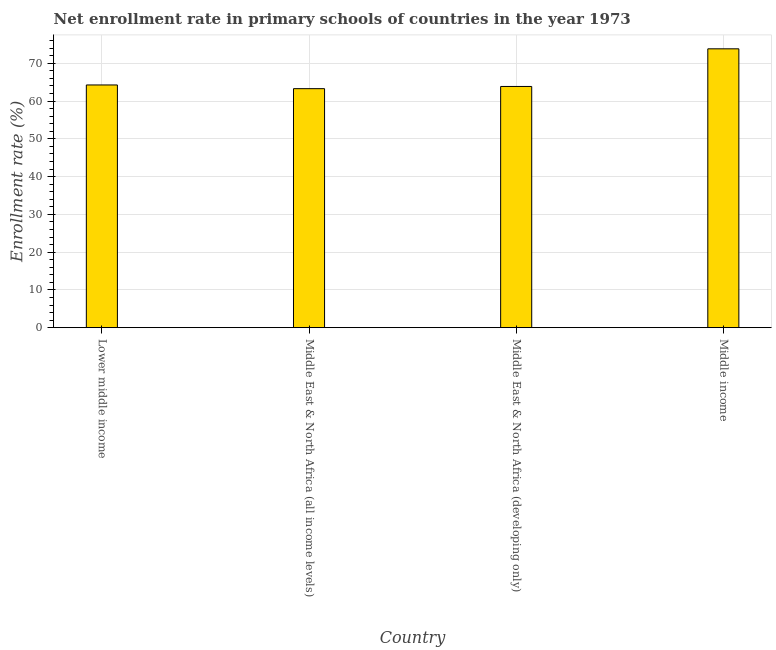What is the title of the graph?
Keep it short and to the point. Net enrollment rate in primary schools of countries in the year 1973. What is the label or title of the X-axis?
Keep it short and to the point. Country. What is the label or title of the Y-axis?
Ensure brevity in your answer.  Enrollment rate (%). What is the net enrollment rate in primary schools in Middle income?
Give a very brief answer. 73.83. Across all countries, what is the maximum net enrollment rate in primary schools?
Make the answer very short. 73.83. Across all countries, what is the minimum net enrollment rate in primary schools?
Your answer should be very brief. 63.28. In which country was the net enrollment rate in primary schools minimum?
Your answer should be very brief. Middle East & North Africa (all income levels). What is the sum of the net enrollment rate in primary schools?
Provide a succinct answer. 265.24. What is the difference between the net enrollment rate in primary schools in Lower middle income and Middle income?
Provide a short and direct response. -9.57. What is the average net enrollment rate in primary schools per country?
Offer a terse response. 66.31. What is the median net enrollment rate in primary schools?
Make the answer very short. 64.06. What is the difference between the highest and the second highest net enrollment rate in primary schools?
Ensure brevity in your answer.  9.57. Is the sum of the net enrollment rate in primary schools in Middle East & North Africa (all income levels) and Middle income greater than the maximum net enrollment rate in primary schools across all countries?
Your response must be concise. Yes. What is the difference between the highest and the lowest net enrollment rate in primary schools?
Make the answer very short. 10.55. Are all the bars in the graph horizontal?
Make the answer very short. No. How many countries are there in the graph?
Your answer should be very brief. 4. What is the difference between two consecutive major ticks on the Y-axis?
Offer a terse response. 10. What is the Enrollment rate (%) of Lower middle income?
Make the answer very short. 64.26. What is the Enrollment rate (%) in Middle East & North Africa (all income levels)?
Keep it short and to the point. 63.28. What is the Enrollment rate (%) of Middle East & North Africa (developing only)?
Provide a succinct answer. 63.86. What is the Enrollment rate (%) in Middle income?
Offer a very short reply. 73.83. What is the difference between the Enrollment rate (%) in Lower middle income and Middle East & North Africa (all income levels)?
Keep it short and to the point. 0.98. What is the difference between the Enrollment rate (%) in Lower middle income and Middle East & North Africa (developing only)?
Give a very brief answer. 0.4. What is the difference between the Enrollment rate (%) in Lower middle income and Middle income?
Your answer should be compact. -9.57. What is the difference between the Enrollment rate (%) in Middle East & North Africa (all income levels) and Middle East & North Africa (developing only)?
Your answer should be very brief. -0.58. What is the difference between the Enrollment rate (%) in Middle East & North Africa (all income levels) and Middle income?
Offer a very short reply. -10.55. What is the difference between the Enrollment rate (%) in Middle East & North Africa (developing only) and Middle income?
Your response must be concise. -9.97. What is the ratio of the Enrollment rate (%) in Lower middle income to that in Middle income?
Offer a terse response. 0.87. What is the ratio of the Enrollment rate (%) in Middle East & North Africa (all income levels) to that in Middle income?
Your response must be concise. 0.86. What is the ratio of the Enrollment rate (%) in Middle East & North Africa (developing only) to that in Middle income?
Provide a succinct answer. 0.86. 